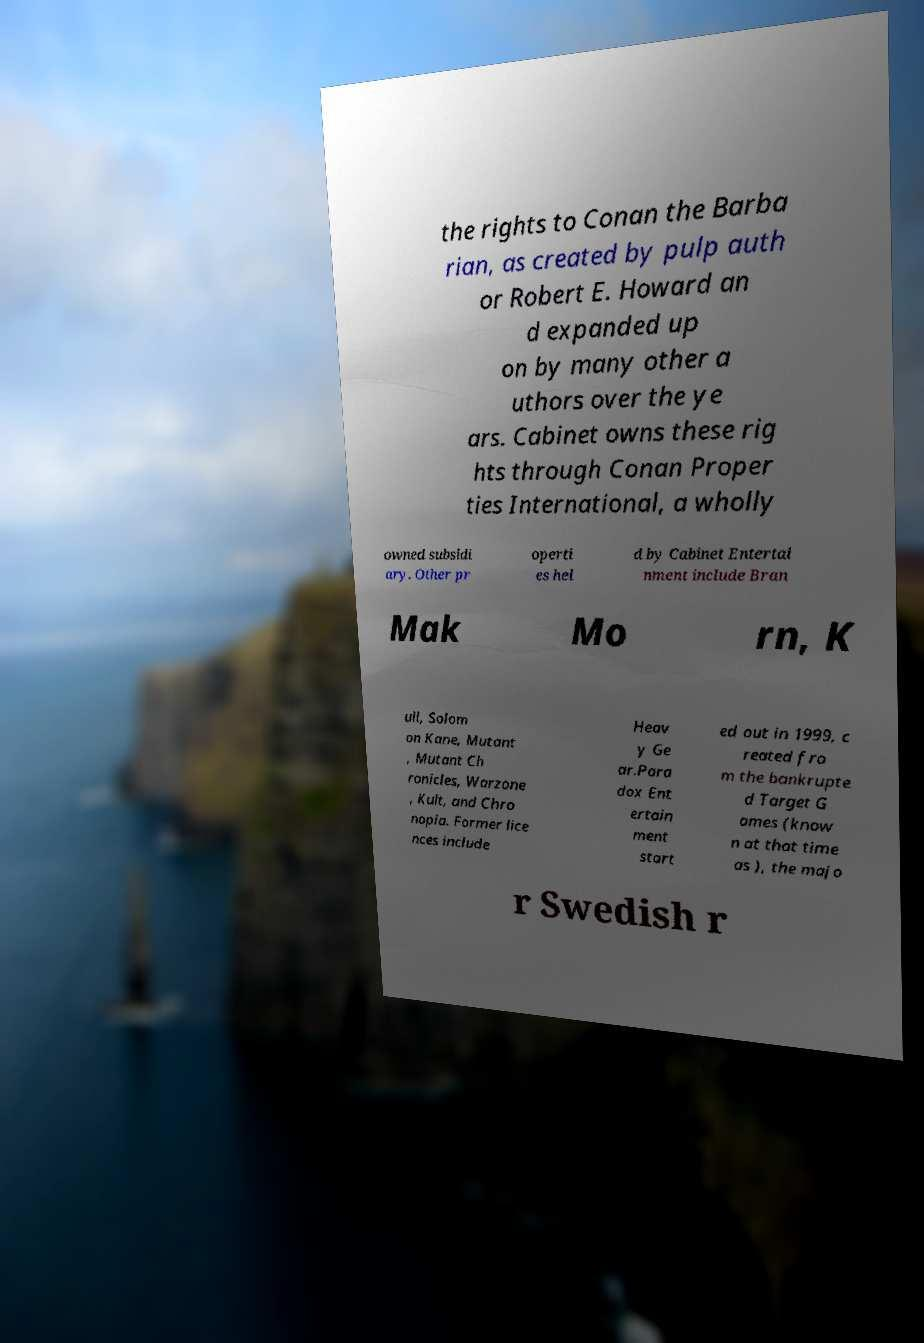Please read and relay the text visible in this image. What does it say? the rights to Conan the Barba rian, as created by pulp auth or Robert E. Howard an d expanded up on by many other a uthors over the ye ars. Cabinet owns these rig hts through Conan Proper ties International, a wholly owned subsidi ary. Other pr operti es hel d by Cabinet Entertai nment include Bran Mak Mo rn, K ull, Solom on Kane, Mutant , Mutant Ch ronicles, Warzone , Kult, and Chro nopia. Former lice nces include Heav y Ge ar.Para dox Ent ertain ment start ed out in 1999, c reated fro m the bankrupte d Target G ames (know n at that time as ), the majo r Swedish r 